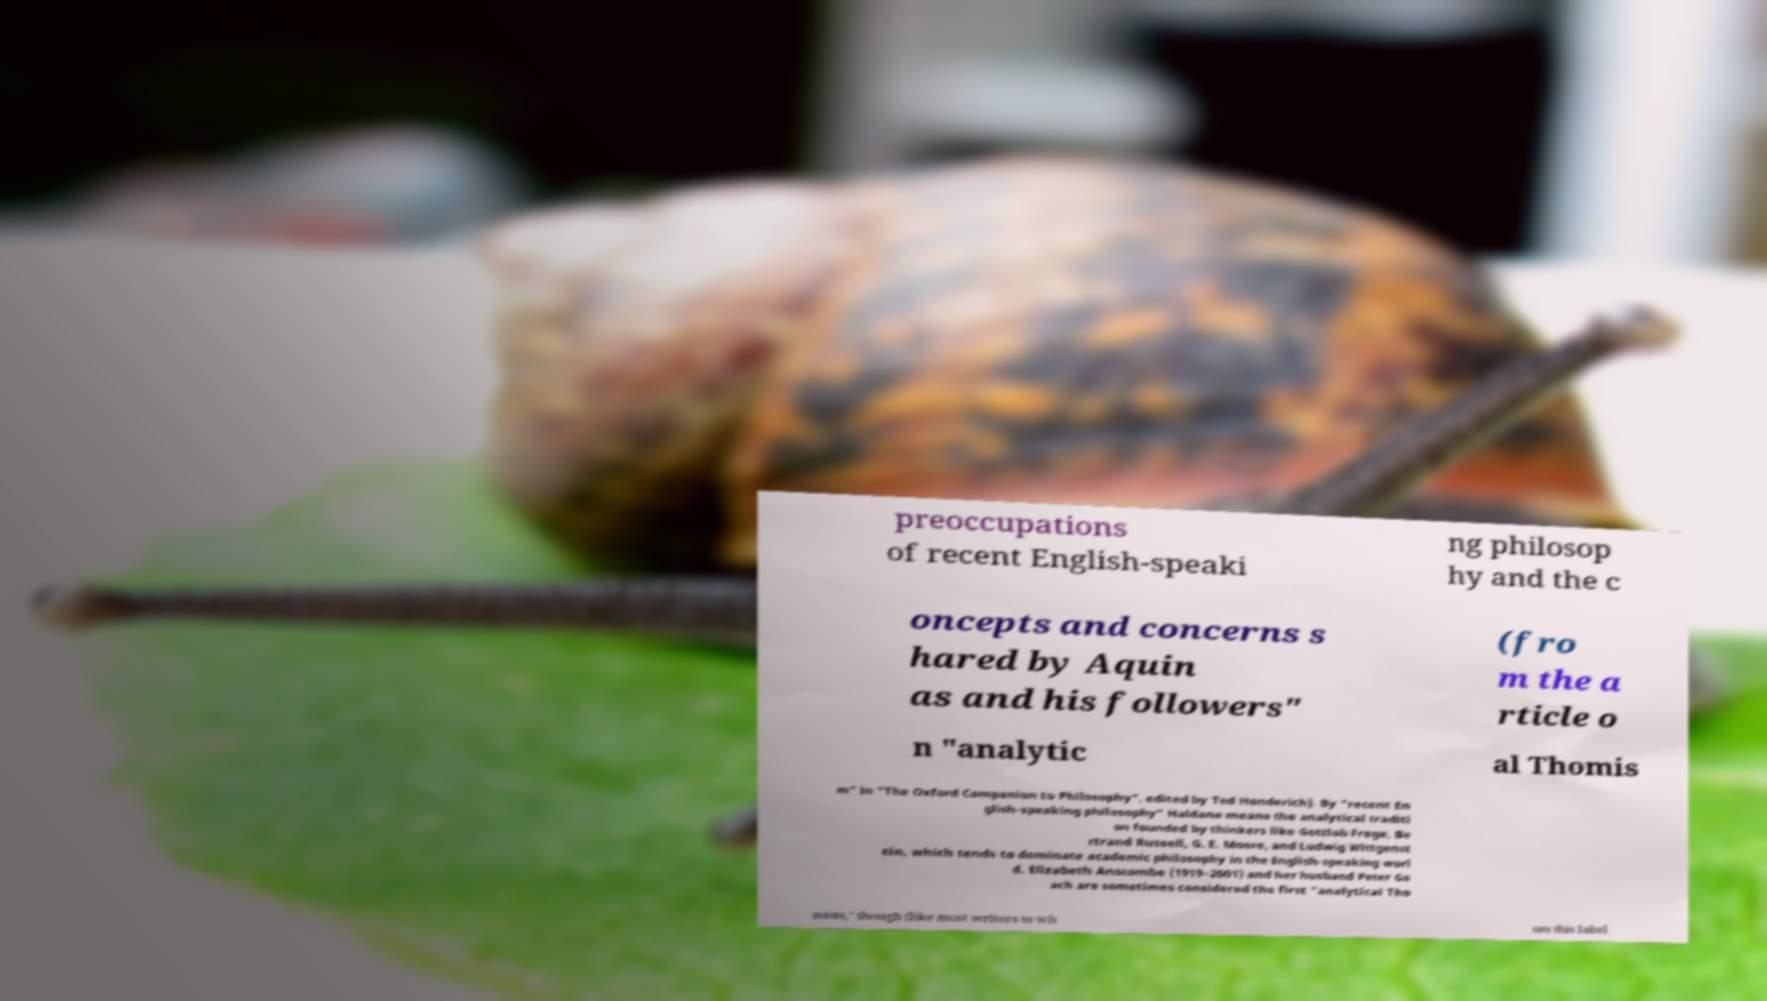Please identify and transcribe the text found in this image. preoccupations of recent English-speaki ng philosop hy and the c oncepts and concerns s hared by Aquin as and his followers" (fro m the a rticle o n "analytic al Thomis m" in "The Oxford Companion to Philosophy", edited by Ted Honderich). By "recent En glish-speaking philosophy" Haldane means the analytical traditi on founded by thinkers like Gottlob Frege, Be rtrand Russell, G. E. Moore, and Ludwig Wittgenst ein, which tends to dominate academic philosophy in the English-speaking worl d. Elizabeth Anscombe (1919–2001) and her husband Peter Ge ach are sometimes considered the first "analytical Tho mists," though (like most writers to wh om this label 